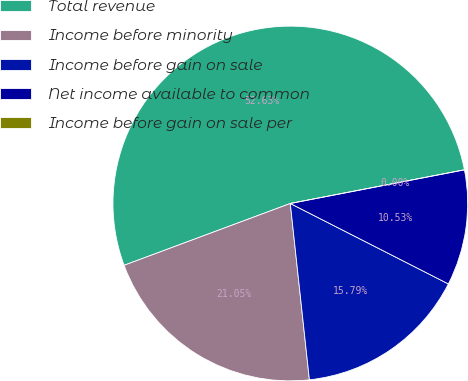Convert chart. <chart><loc_0><loc_0><loc_500><loc_500><pie_chart><fcel>Total revenue<fcel>Income before minority<fcel>Income before gain on sale<fcel>Net income available to common<fcel>Income before gain on sale per<nl><fcel>52.63%<fcel>21.05%<fcel>15.79%<fcel>10.53%<fcel>0.0%<nl></chart> 